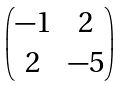Convert formula to latex. <formula><loc_0><loc_0><loc_500><loc_500>\begin{pmatrix} - 1 & 2 \\ 2 & - 5 \end{pmatrix}</formula> 